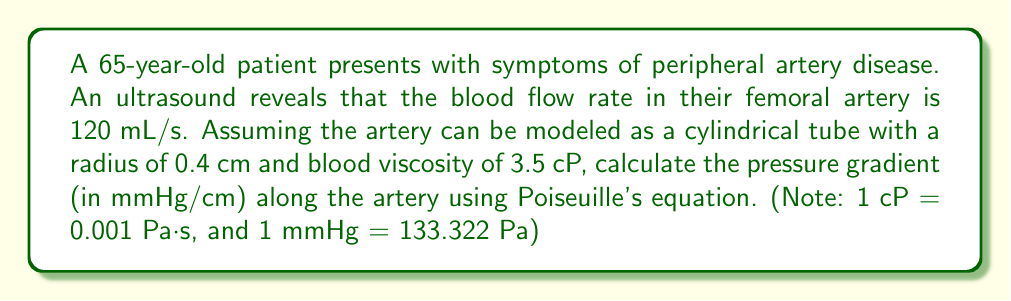Help me with this question. To solve this problem, we'll use Poiseuille's equation, which relates the pressure gradient to the flow rate in a cylindrical tube:

$$\Delta P = \frac{8\mu LQ}{\pi r^4}$$

Where:
$\Delta P$ = pressure gradient (Pa/m)
$\mu$ = dynamic viscosity (Pa·s)
$L$ = length of the tube (m)
$Q$ = volumetric flow rate (m³/s)
$r$ = radius of the tube (m)

Step 1: Convert given values to SI units
- Flow rate: $Q = 120 \text{ mL/s} = 1.2 \times 10^{-4} \text{ m³/s}$
- Radius: $r = 0.4 \text{ cm} = 0.004 \text{ m}$
- Viscosity: $\mu = 3.5 \text{ cP} = 0.0035 \text{ Pa·s}$

Step 2: Rearrange Poiseuille's equation to solve for $\Delta P/L$ (pressure gradient per unit length)

$$\frac{\Delta P}{L} = \frac{8\mu Q}{\pi r^4}$$

Step 3: Substitute the values and calculate

$$\frac{\Delta P}{L} = \frac{8 \times 0.0035 \times 1.2 \times 10^{-4}}{\pi \times (0.004)^4} = 2,081.76 \text{ Pa/m}$$

Step 4: Convert the result to mmHg/cm

$$2,081.76 \text{ Pa/m} \times \frac{1 \text{ mmHg}}{133.322 \text{ Pa}} \times \frac{1 \text{ m}}{100 \text{ cm}} = 0.1562 \text{ mmHg/cm}$$
Answer: 0.1562 mmHg/cm 